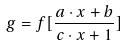<formula> <loc_0><loc_0><loc_500><loc_500>g = f [ \frac { a \cdot x + b } { c \cdot x + 1 } ]</formula> 